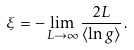Convert formula to latex. <formula><loc_0><loc_0><loc_500><loc_500>\xi = - \lim _ { L \to \infty } \frac { 2 L } { \langle \ln g \rangle } \, .</formula> 